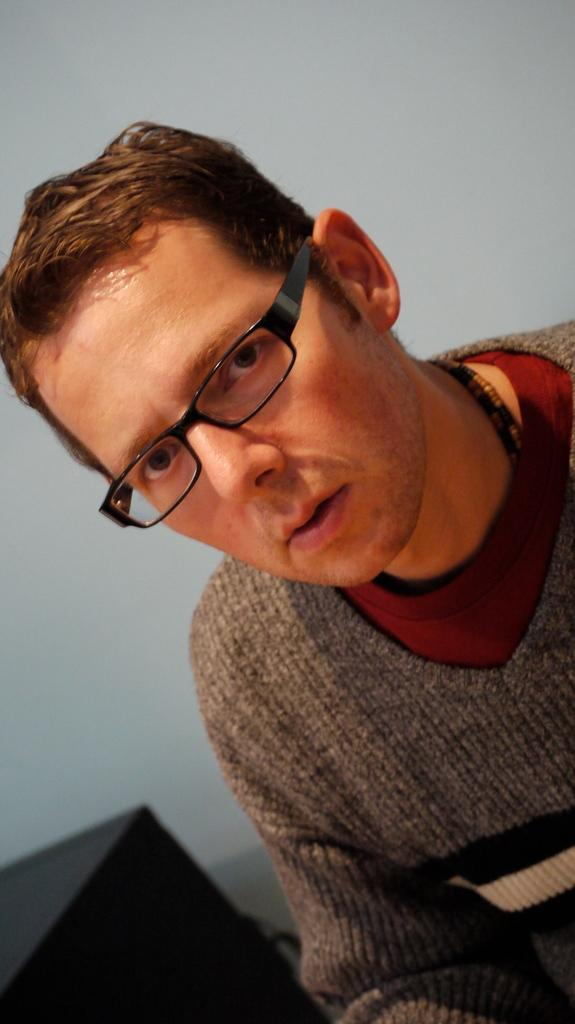Who is the main subject in the image? There is a person in the center of the image. What is the person wearing? The person is wearing a sweater. What can be seen in the background of the image? There is a wall in the background of the image. What object is located to the left side of the image? There is a table to the left side of the image. What type of caption is written on the sweater in the image? There is no caption written on the sweater in the image; it is just a plain sweater. How much lettuce can be seen on the table in the image? There is no lettuce present in the image; the table is empty except for the person. 